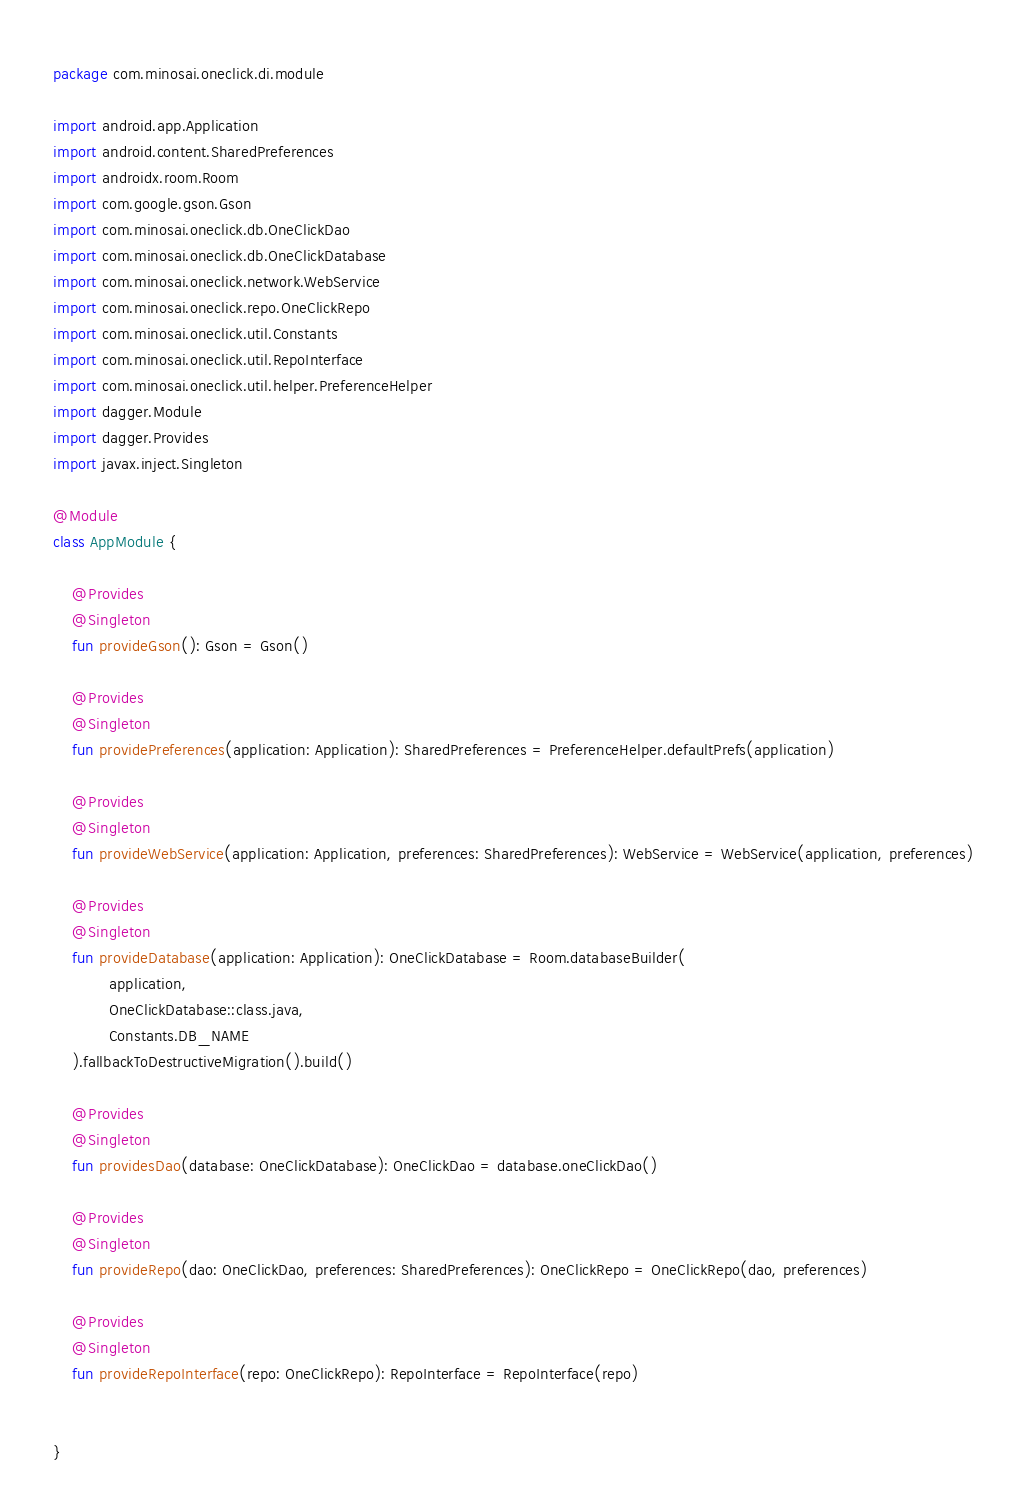<code> <loc_0><loc_0><loc_500><loc_500><_Kotlin_>package com.minosai.oneclick.di.module

import android.app.Application
import android.content.SharedPreferences
import androidx.room.Room
import com.google.gson.Gson
import com.minosai.oneclick.db.OneClickDao
import com.minosai.oneclick.db.OneClickDatabase
import com.minosai.oneclick.network.WebService
import com.minosai.oneclick.repo.OneClickRepo
import com.minosai.oneclick.util.Constants
import com.minosai.oneclick.util.RepoInterface
import com.minosai.oneclick.util.helper.PreferenceHelper
import dagger.Module
import dagger.Provides
import javax.inject.Singleton

@Module
class AppModule {

    @Provides
    @Singleton
    fun provideGson(): Gson = Gson()

    @Provides
    @Singleton
    fun providePreferences(application: Application): SharedPreferences = PreferenceHelper.defaultPrefs(application)

    @Provides
    @Singleton
    fun provideWebService(application: Application, preferences: SharedPreferences): WebService = WebService(application, preferences)

    @Provides
    @Singleton
    fun provideDatabase(application: Application): OneClickDatabase = Room.databaseBuilder(
            application,
            OneClickDatabase::class.java,
            Constants.DB_NAME
    ).fallbackToDestructiveMigration().build()

    @Provides
    @Singleton
    fun providesDao(database: OneClickDatabase): OneClickDao = database.oneClickDao()

    @Provides
    @Singleton
    fun provideRepo(dao: OneClickDao, preferences: SharedPreferences): OneClickRepo = OneClickRepo(dao, preferences)

    @Provides
    @Singleton
    fun provideRepoInterface(repo: OneClickRepo): RepoInterface = RepoInterface(repo)


}</code> 